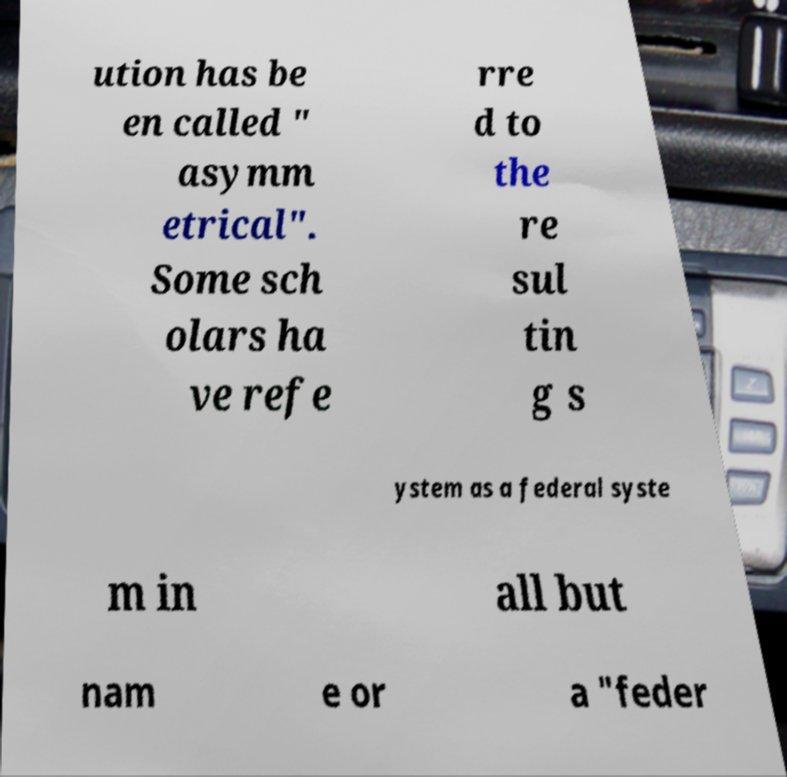Could you assist in decoding the text presented in this image and type it out clearly? ution has be en called " asymm etrical". Some sch olars ha ve refe rre d to the re sul tin g s ystem as a federal syste m in all but nam e or a "feder 